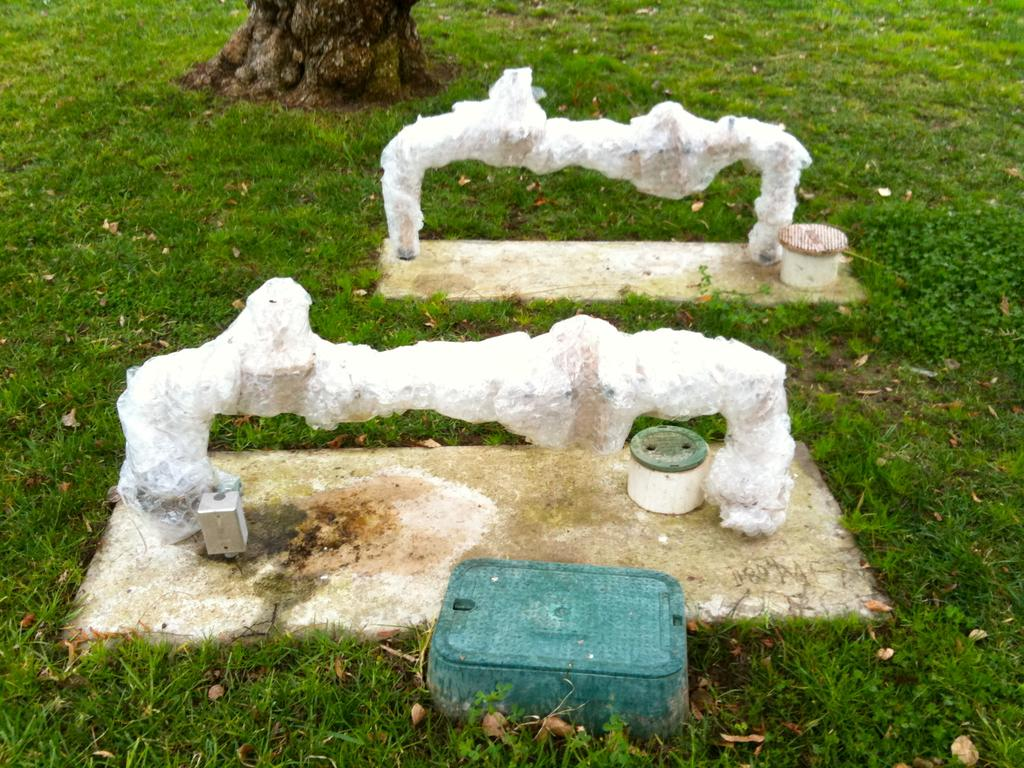What is covering the ground in the image? The ground is covered with objects in the image. What type of vegetation can be seen in the image? There is grass visible in the image. What additional objects can be found on the ground? Dried leaves are present in the image. Where is the trunk of a tree located in the image? The trunk of a tree is visible at the top of the image. What type of card is being used to measure the height of the tree in the image? There is no card present in the image, nor is there any indication of measuring the height of the tree. 